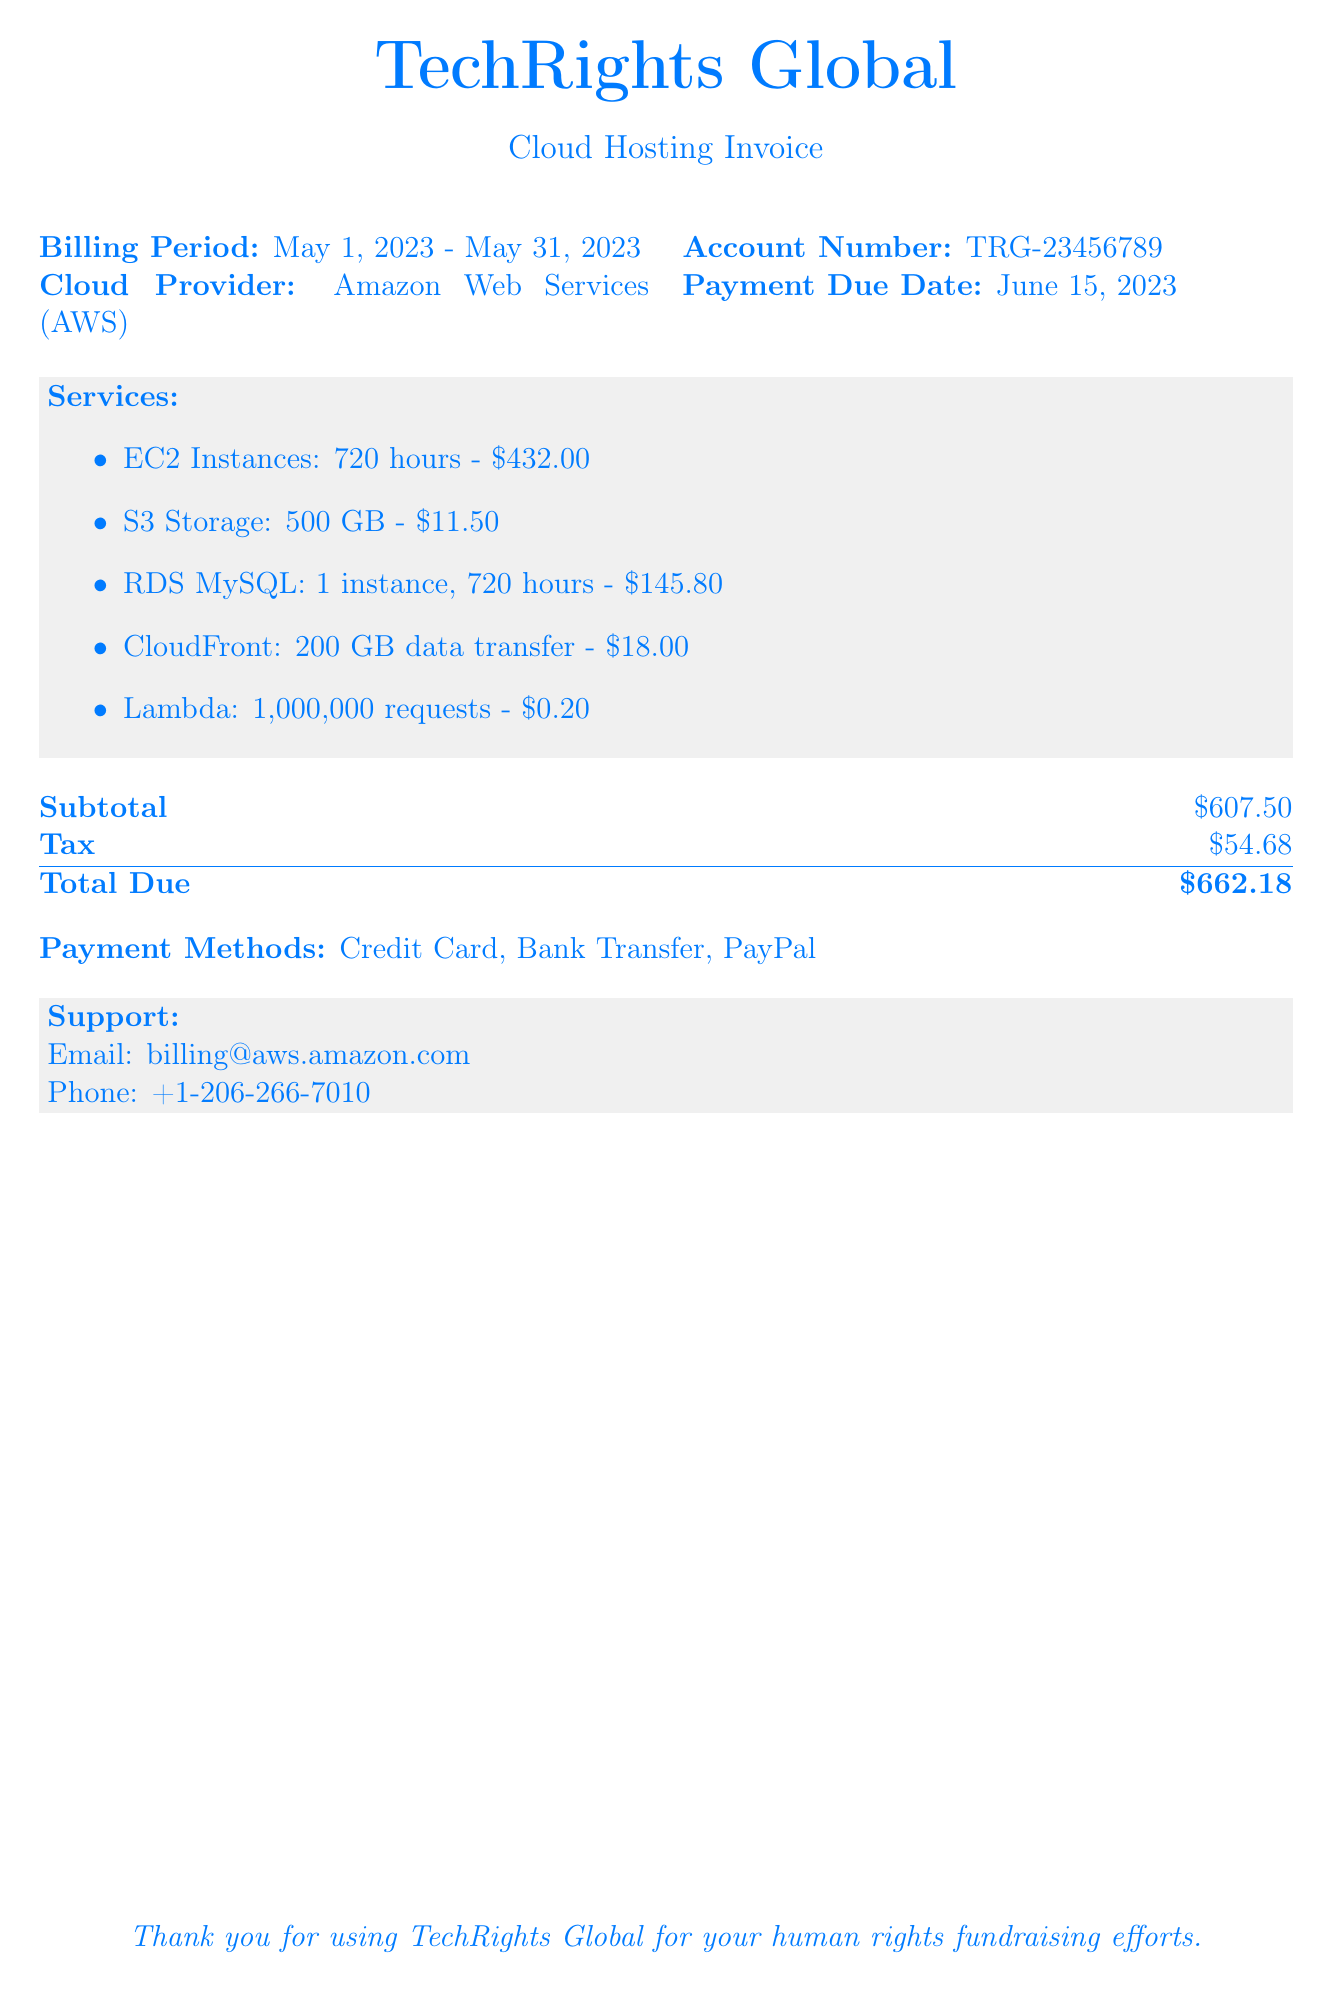What is the billing period? The billing period is specified in the document as May 1, 2023 to May 31, 2023.
Answer: May 1, 2023 - May 31, 2023 What is the account number? The account number is stated in the document, which is unique to the organization.
Answer: TRG-23456789 What is the total amount due? The total amount due is shown at the bottom of the invoice, including tax.
Answer: $662.18 Which cloud provider is used? The document specifically mentions the cloud provider being used for the services.
Answer: Amazon Web Services (AWS) How many hours of EC2 Instances were billed? This information is provided in the services list, where the EC2 instances billing is detailed.
Answer: 720 hours What is the tax amount? The tax amount is listed on the bill and is added to the subtotal to determine the total due.
Answer: $54.68 Which service had the highest cost? The services are listed with their respective costs, and one can compare these to determine the highest.
Answer: EC2 Instances How many gigabytes of data transfer does CloudFront handle? The data transfer details for CloudFront are represented in the services section of the document.
Answer: 200 GB What payment methods are available? The document lists options for payment methods at the bottom of the bill.
Answer: Credit Card, Bank Transfer, PayPal 